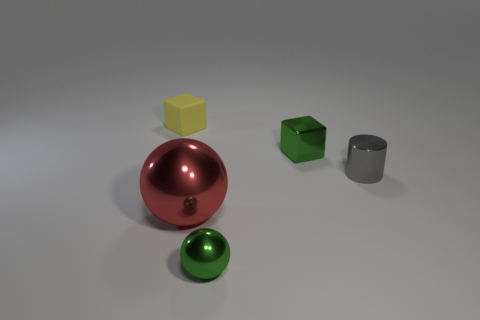Subtract all yellow blocks. How many blocks are left? 1 Subtract all balls. How many objects are left? 3 Subtract 1 spheres. How many spheres are left? 1 Subtract all brown cylinders. How many blue blocks are left? 0 Add 3 yellow things. How many yellow things are left? 4 Add 5 small green spheres. How many small green spheres exist? 6 Add 4 big shiny things. How many objects exist? 9 Subtract 0 blue spheres. How many objects are left? 5 Subtract all green spheres. Subtract all blue cubes. How many spheres are left? 1 Subtract all small yellow matte blocks. Subtract all big green metallic spheres. How many objects are left? 4 